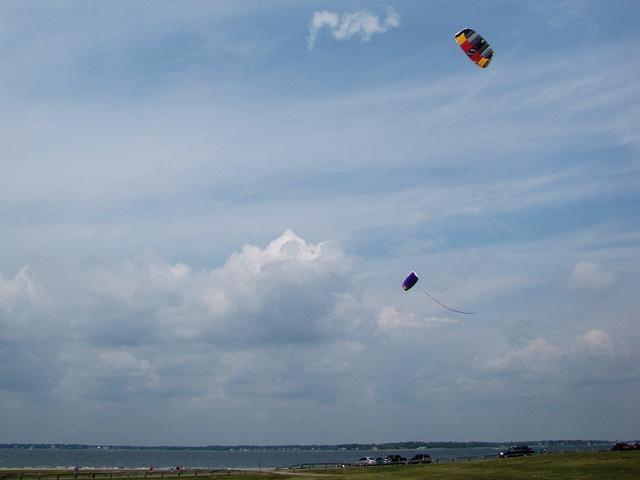How many train cars are under the poles?
Give a very brief answer. 0. 